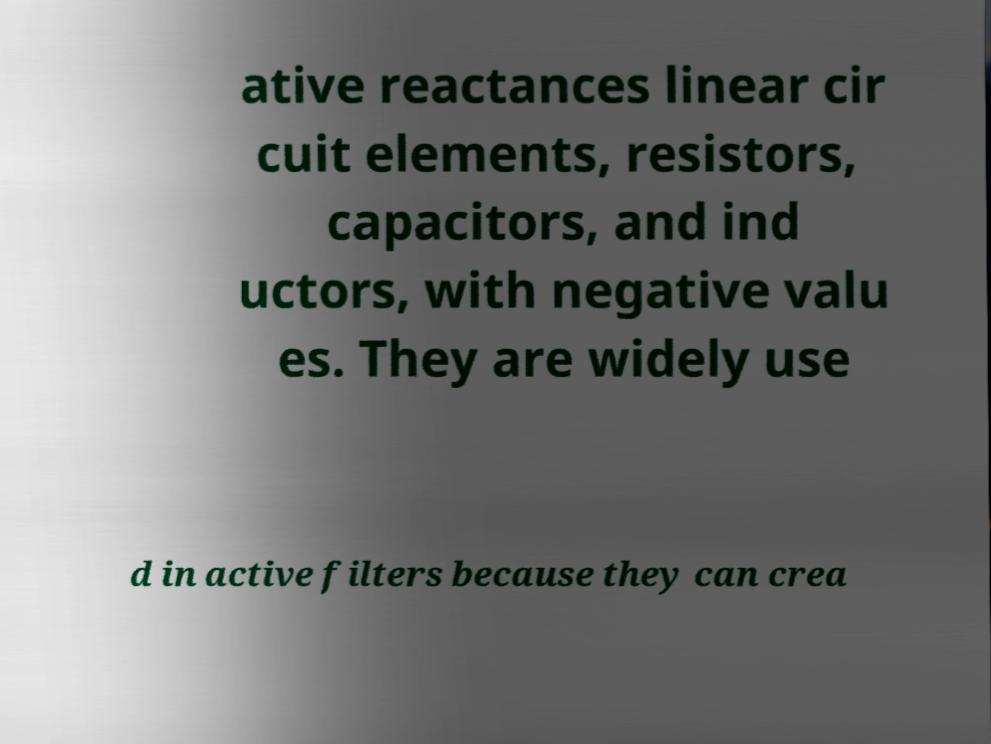There's text embedded in this image that I need extracted. Can you transcribe it verbatim? ative reactances linear cir cuit elements, resistors, capacitors, and ind uctors, with negative valu es. They are widely use d in active filters because they can crea 